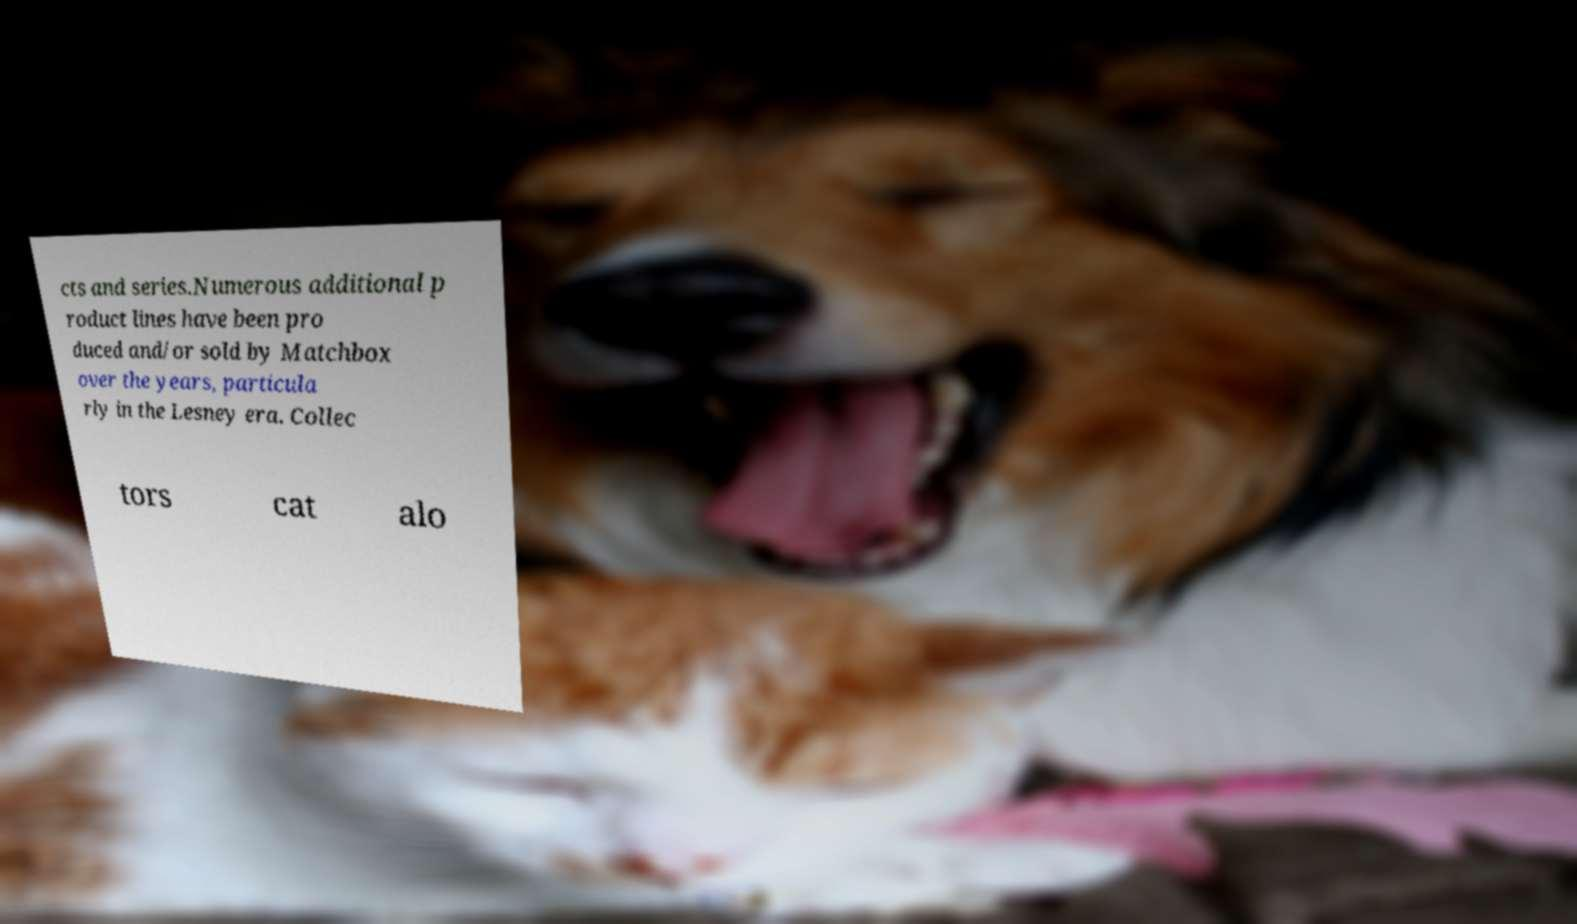Could you assist in decoding the text presented in this image and type it out clearly? cts and series.Numerous additional p roduct lines have been pro duced and/or sold by Matchbox over the years, particula rly in the Lesney era. Collec tors cat alo 